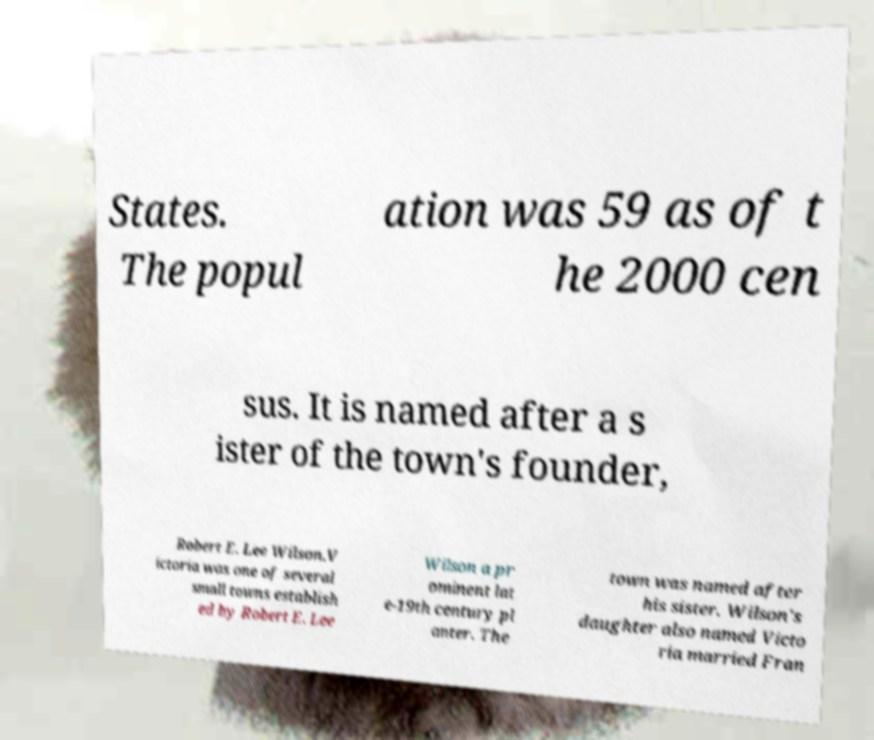Please identify and transcribe the text found in this image. States. The popul ation was 59 as of t he 2000 cen sus. It is named after a s ister of the town's founder, Robert E. Lee Wilson.V ictoria was one of several small towns establish ed by Robert E. Lee Wilson a pr ominent lat e-19th century pl anter. The town was named after his sister. Wilson's daughter also named Victo ria married Fran 